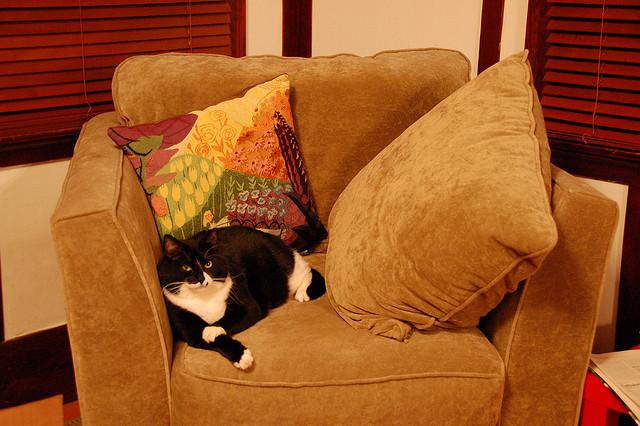Are the cat's eyes open?
Quick response, please. Yes. Is the cat sleeping on the pillows?
Keep it brief. No. Are both pillows the same color?
Answer briefly. No. 